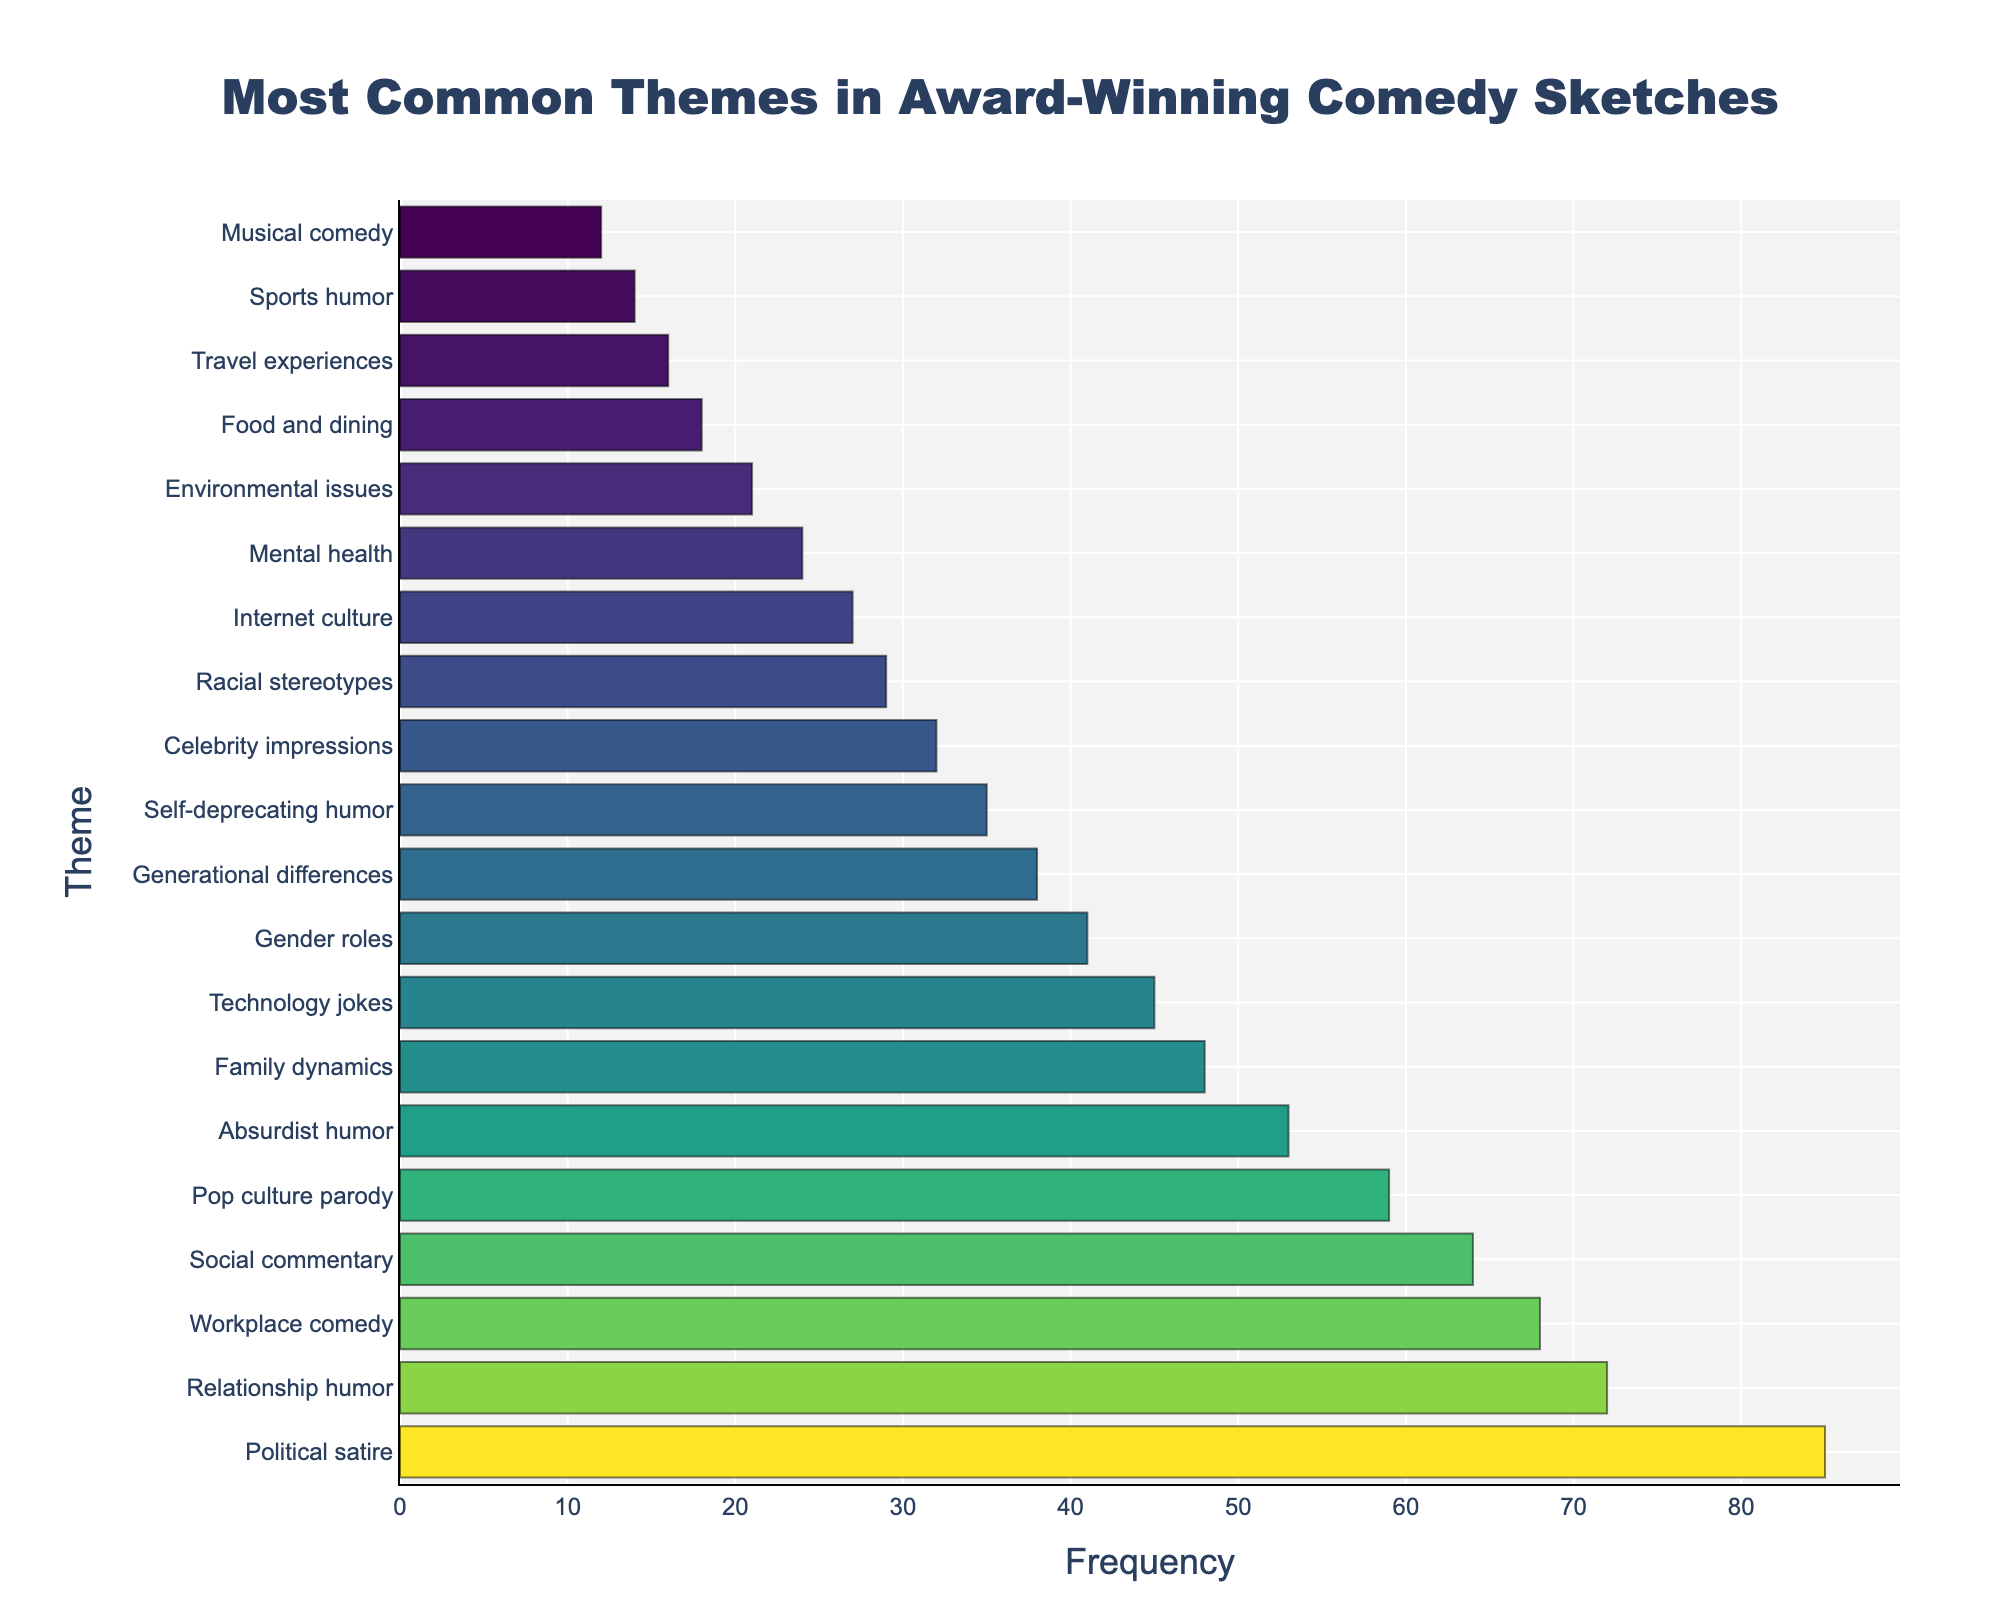Which theme has the highest frequency among award-winning comedy sketches? The bar chart shows that 'Political satire' has the longest bar, indicating it has the highest frequency among the themes.
Answer: Political satire Which two themes have the closest frequencies? By visually comparing the lengths of the bars, 'Internet culture' (27) and 'Racial stereotypes' (29) have the closest frequencies, with only a 2-unit difference.
Answer: Internet culture and Racial stereotypes What is the total frequency of 'Relationship humor' and 'Workplace comedy'? 'Relationship humor' has a frequency of 72, and 'Workplace comedy' is at 68. Summing them up: 72 + 68 = 140.
Answer: 140 How much more frequent is 'Family dynamics' compared to 'Music comedy'? 'Family dynamics' has a frequency of 48, and 'Music comedy' has 12. The difference is 48 - 12 = 36.
Answer: 36 Which theme has the shortest bar and how frequent is it? The theme with the shortest bar is 'Musical comedy', which has a frequency of 12.
Answer: Musical comedy, 12 What is the combined frequency of the least common five themes? The least common five themes are 'Musical comedy' (12), 'Sports humor' (14), 'Travel experiences' (16), 'Food and dining' (18), and 'Environmental issues' (21). Their combined frequency is 12 + 14 + 16 + 18 + 21 = 81.
Answer: 81 Which theme has a frequency exactly in the middle of the list? Sorting the themes by frequency, 'Gender roles' is approximately in the middle with a frequency of 41.
Answer: Gender roles How do the frequencies of 'Absurdist humor' and 'Technology jokes' compare? 'Absurdist humor' has a frequency of 53, and 'Technology jokes' has 45. 'Absurdist humor' is more frequent.
Answer: Absurdist humor is more frequent Among the top three most frequent themes, which stands second? After 'Political satire' (85), 'Relationship humor' has the second-highest frequency at 72.
Answer: Relationship humor What is the difference in frequency between 'Social commentary' and 'Pop culture parody'? 'Social commentary' has a frequency of 64, and 'Pop culture parody' has 59. The difference is 64 - 59 = 5.
Answer: 5 